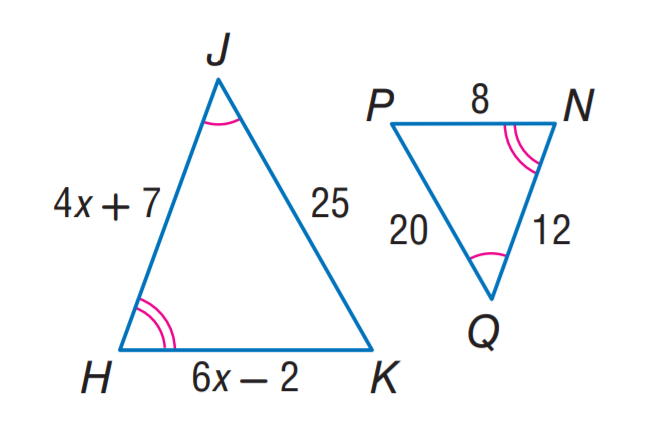Question: Find H K.
Choices:
A. 10
B. 12
C. 15
D. 20
Answer with the letter. Answer: A Question: Find H J.
Choices:
A. 10
B. 12
C. 15
D. 25
Answer with the letter. Answer: C 